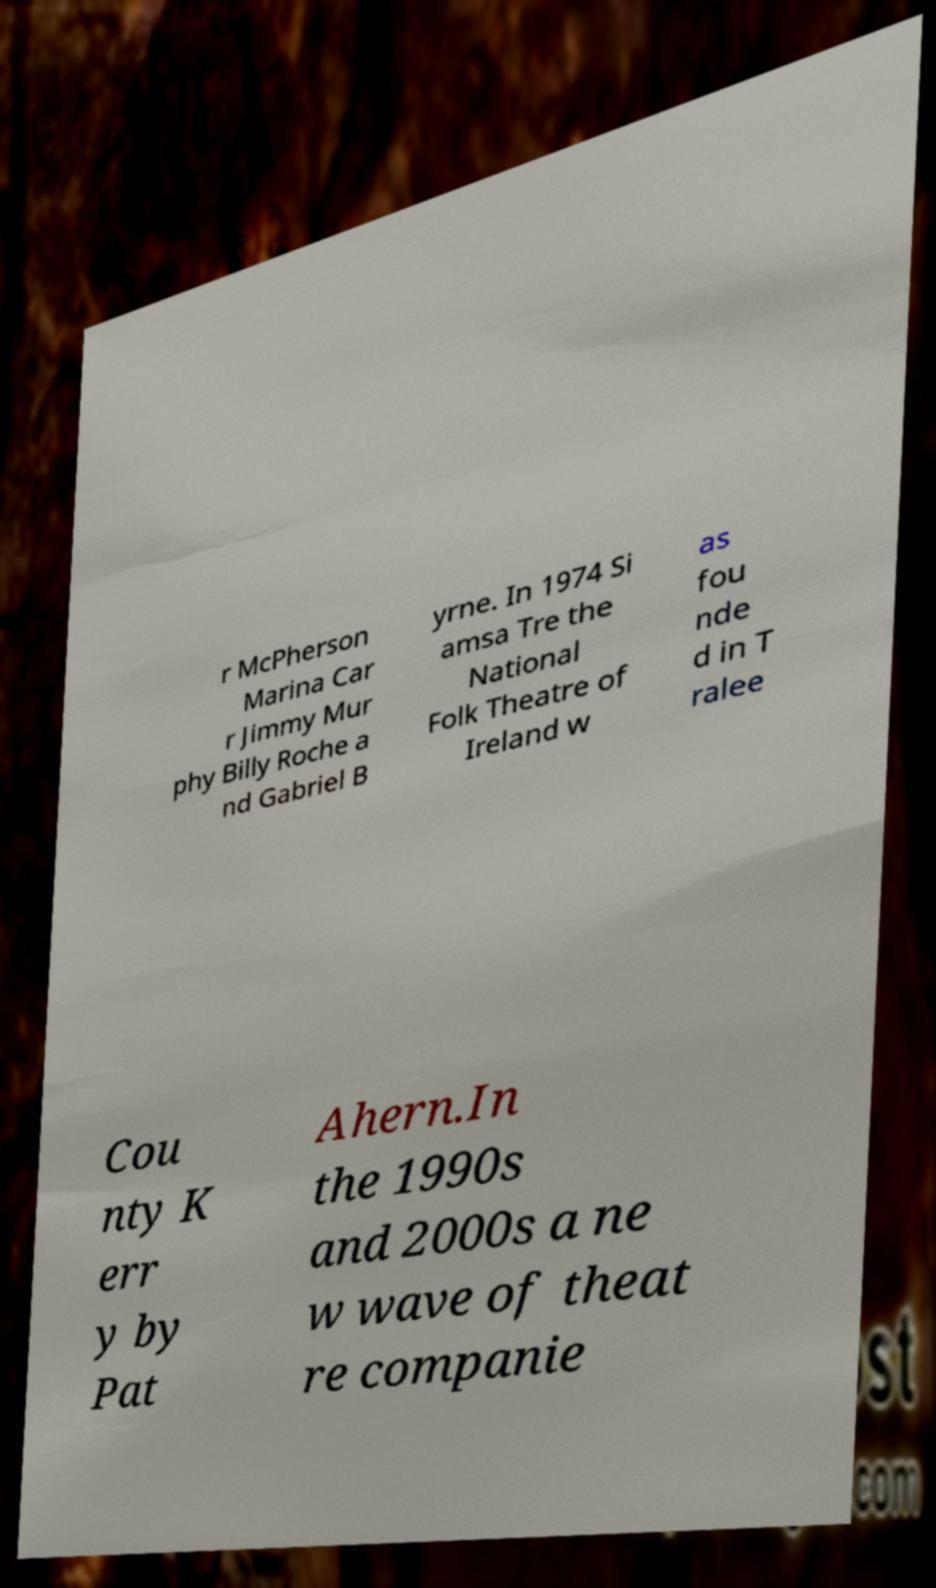Could you extract and type out the text from this image? r McPherson Marina Car r Jimmy Mur phy Billy Roche a nd Gabriel B yrne. In 1974 Si amsa Tre the National Folk Theatre of Ireland w as fou nde d in T ralee Cou nty K err y by Pat Ahern.In the 1990s and 2000s a ne w wave of theat re companie 